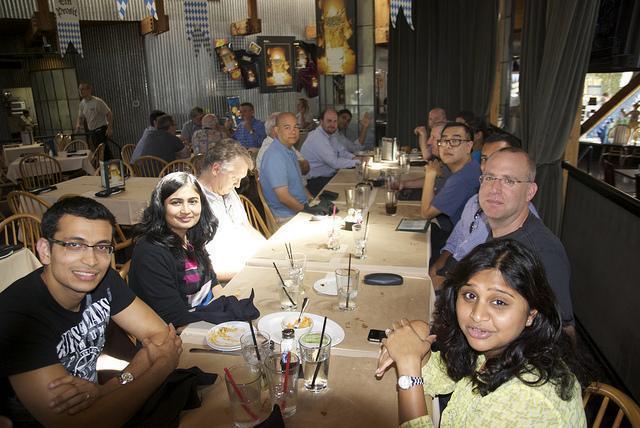How many people can be seen?
Give a very brief answer. 11. How many dining tables can be seen?
Give a very brief answer. 3. 